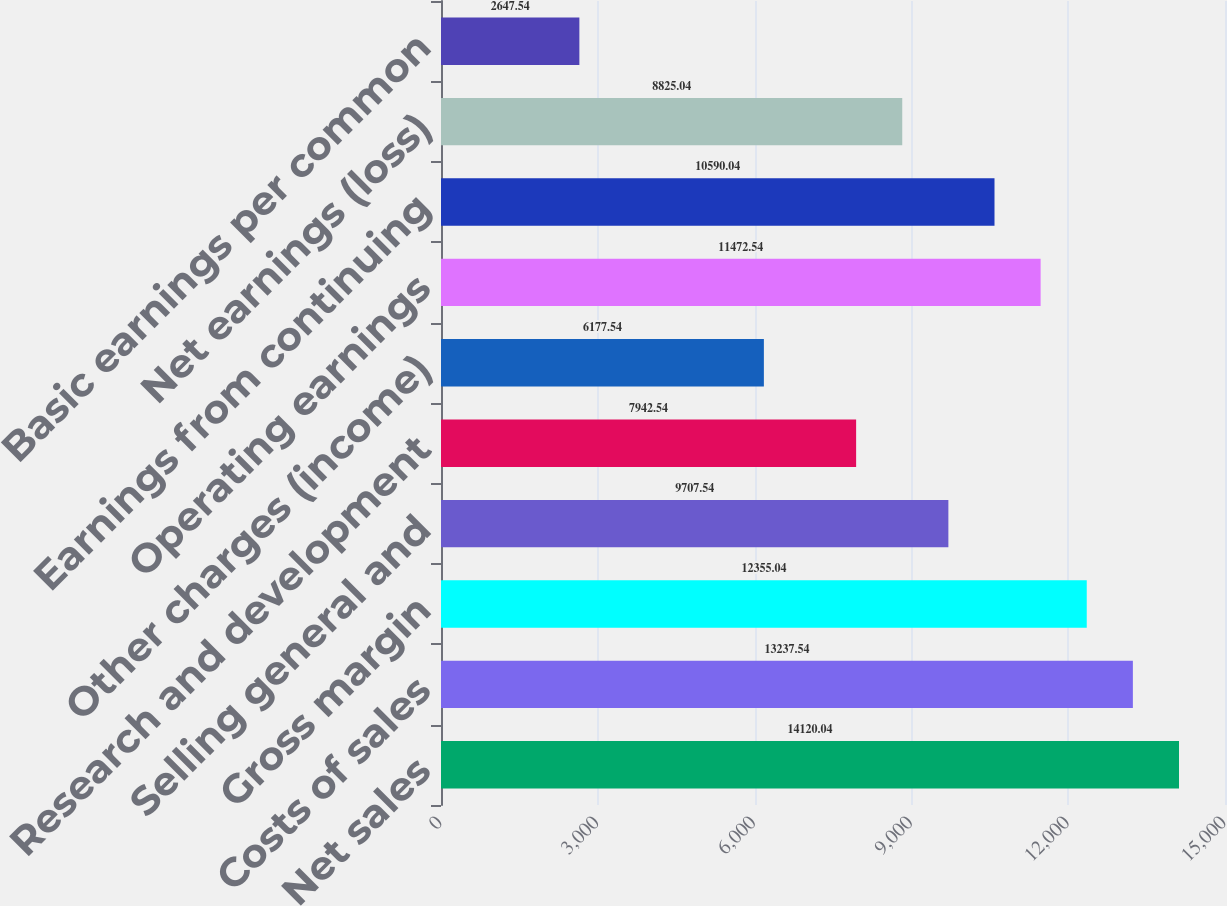Convert chart to OTSL. <chart><loc_0><loc_0><loc_500><loc_500><bar_chart><fcel>Net sales<fcel>Costs of sales<fcel>Gross margin<fcel>Selling general and<fcel>Research and development<fcel>Other charges (income)<fcel>Operating earnings<fcel>Earnings from continuing<fcel>Net earnings (loss)<fcel>Basic earnings per common<nl><fcel>14120<fcel>13237.5<fcel>12355<fcel>9707.54<fcel>7942.54<fcel>6177.54<fcel>11472.5<fcel>10590<fcel>8825.04<fcel>2647.54<nl></chart> 